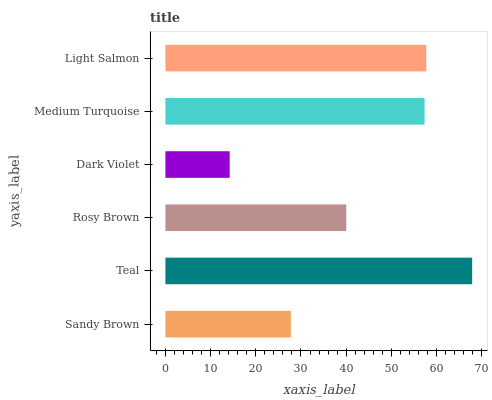Is Dark Violet the minimum?
Answer yes or no. Yes. Is Teal the maximum?
Answer yes or no. Yes. Is Rosy Brown the minimum?
Answer yes or no. No. Is Rosy Brown the maximum?
Answer yes or no. No. Is Teal greater than Rosy Brown?
Answer yes or no. Yes. Is Rosy Brown less than Teal?
Answer yes or no. Yes. Is Rosy Brown greater than Teal?
Answer yes or no. No. Is Teal less than Rosy Brown?
Answer yes or no. No. Is Medium Turquoise the high median?
Answer yes or no. Yes. Is Rosy Brown the low median?
Answer yes or no. Yes. Is Sandy Brown the high median?
Answer yes or no. No. Is Sandy Brown the low median?
Answer yes or no. No. 